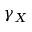Convert formula to latex. <formula><loc_0><loc_0><loc_500><loc_500>\gamma _ { X }</formula> 